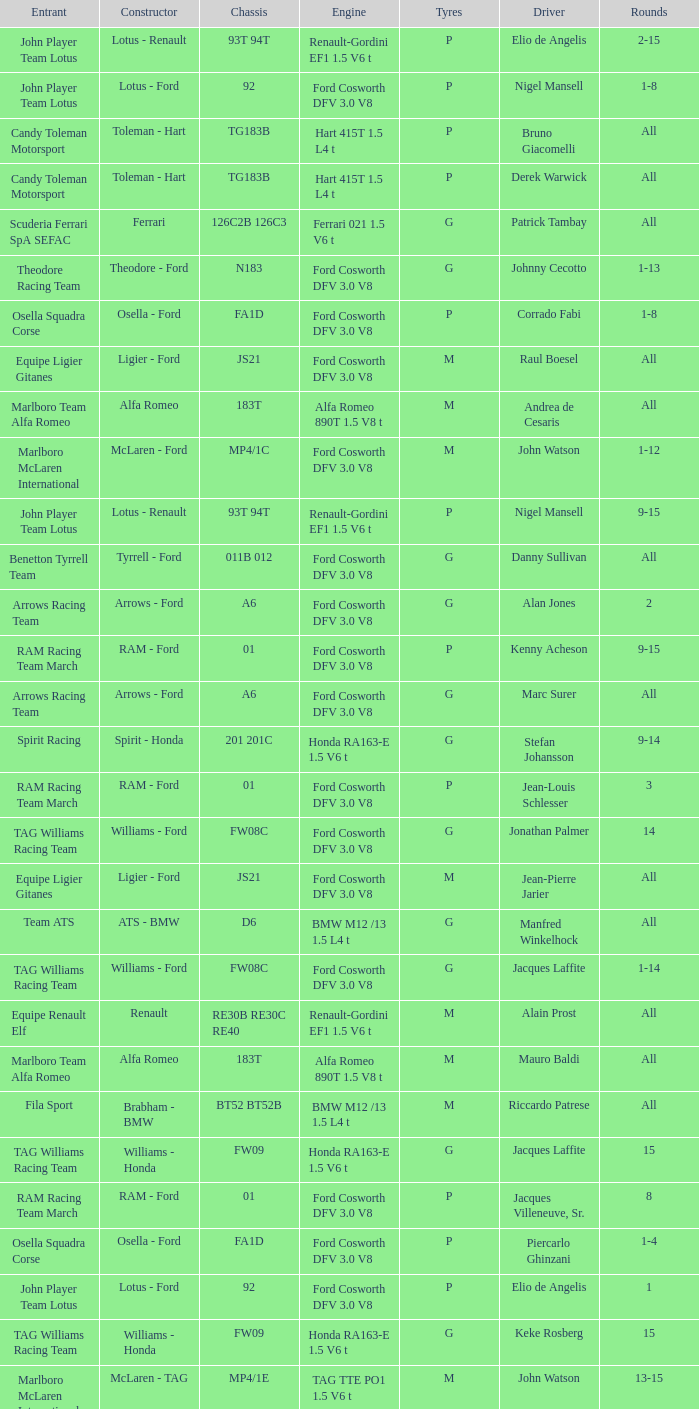Who is the constructor for driver Niki Lauda and a chassis of mp4/1c? McLaren - Ford. 